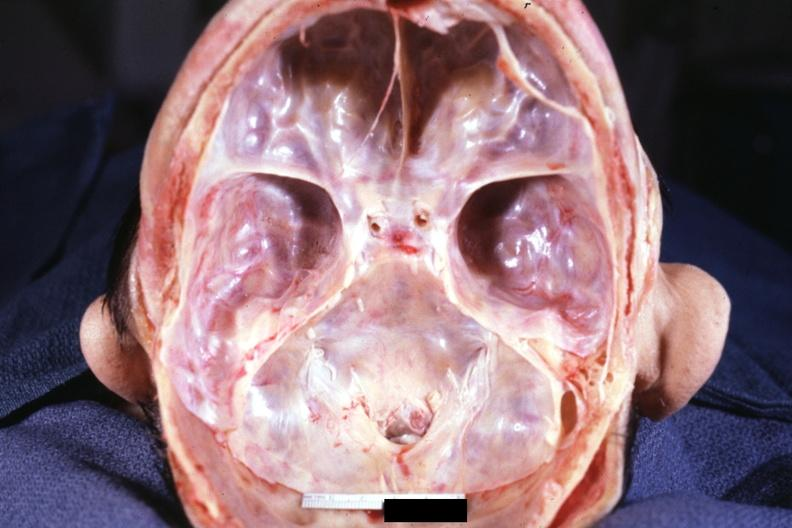does nodular tumor show stenosis of foramen magnum due to subluxation of atlas vertebra case 31?
Answer the question using a single word or phrase. No 